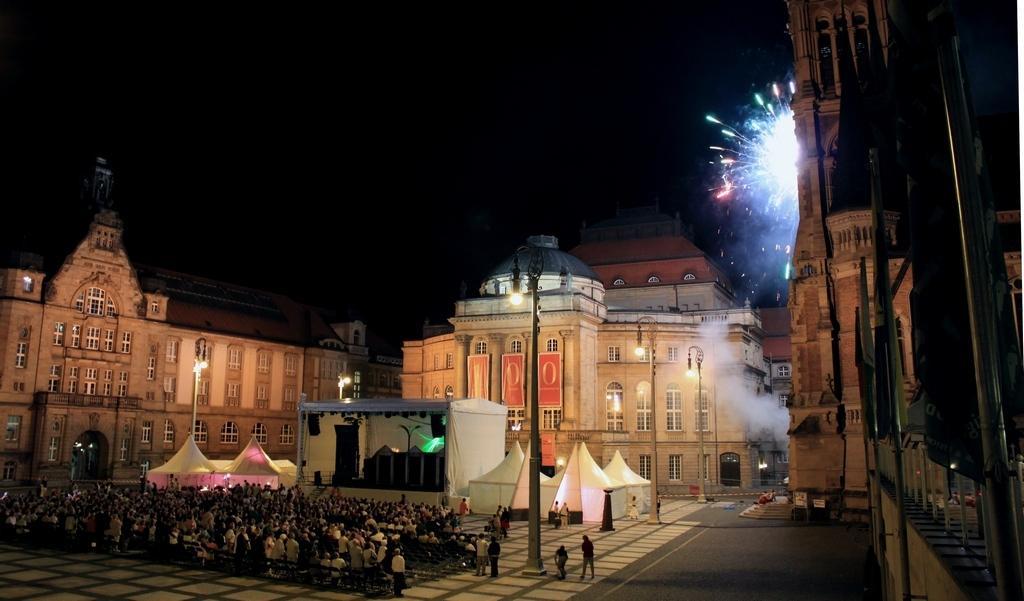Please provide a concise description of this image. In this image I can see number of persons sitting and few persons are standing on the ground. I can see the road, few tents which are white in color, the stage, few poles, few lights and few buildings. In the background I can see the dark sky and few crackers exploding. 